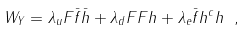<formula> <loc_0><loc_0><loc_500><loc_500>W _ { Y } = \lambda _ { u } F \bar { f } \bar { h } + \lambda _ { d } F F h + \lambda _ { e } \bar { f } h ^ { c } h \ ,</formula> 